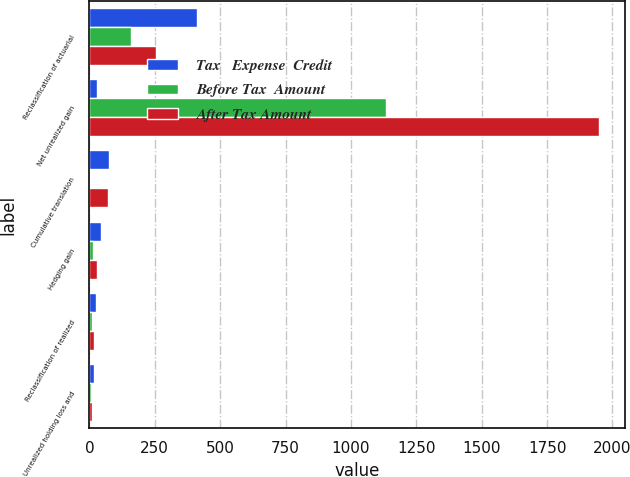<chart> <loc_0><loc_0><loc_500><loc_500><stacked_bar_chart><ecel><fcel>Reclassification of actuarial<fcel>Net unrealized gain<fcel>Cumulative translation<fcel>Hedging gain<fcel>Reclassification of realized<fcel>Unrealized holding loss and<nl><fcel>Tax   Expense  Credit<fcel>412<fcel>29<fcel>74<fcel>43<fcel>27<fcel>17<nl><fcel>Before Tax  Amount<fcel>158<fcel>1136<fcel>3<fcel>14<fcel>9<fcel>6<nl><fcel>After Tax Amount<fcel>254<fcel>1950<fcel>71<fcel>29<fcel>18<fcel>11<nl></chart> 